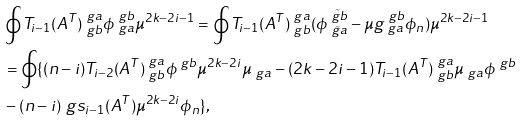Convert formula to latex. <formula><loc_0><loc_0><loc_500><loc_500>& \oint T _ { i - 1 } ( A ^ { T } ) ^ { \ g a } _ { \ g b } \phi ^ { \ g b } _ { \ g a } \mu ^ { 2 k - 2 i - 1 } = \oint T _ { i - 1 } ( A ^ { T } ) ^ { \ g a } _ { \ g b } ( \phi ^ { \tilde { \ g b } } _ { \tilde { \ g a } } - \mu g ^ { \ g b } _ { \ g a } \phi _ { n } ) \mu ^ { 2 k - 2 i - 1 } \\ & = \oint \{ ( n - i ) T _ { i - 2 } ( A ^ { T } ) ^ { \ g a } _ { \ g b } \phi ^ { \ g b } \mu ^ { 2 k - 2 i } \mu _ { \ g a } - ( 2 k - 2 i - 1 ) T _ { i - 1 } ( A ^ { T } ) ^ { \ g a } _ { \ g b } \mu _ { \ g a } \phi ^ { \ g b } \\ & - ( n - i ) \ g s _ { i - 1 } ( A ^ { T } ) \mu ^ { 2 k - 2 i } \phi _ { n } \} ,</formula> 